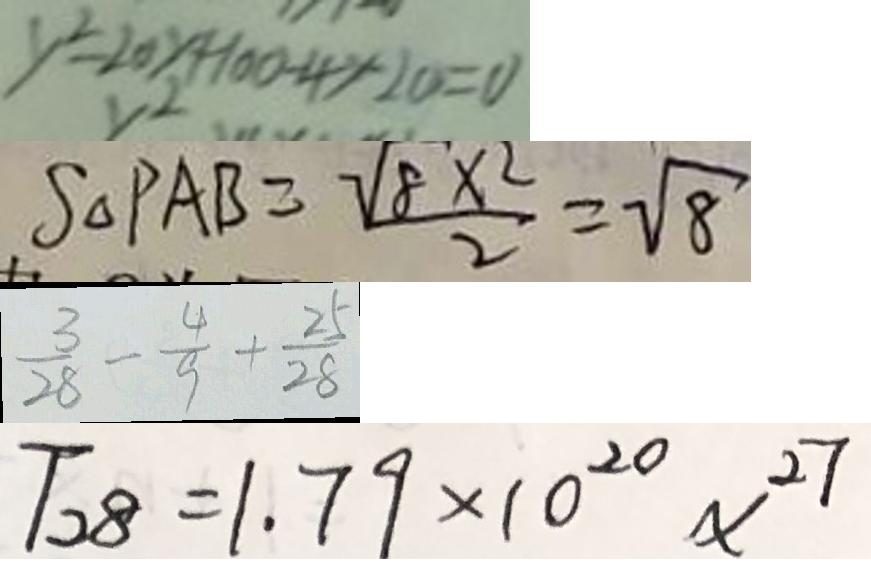<formula> <loc_0><loc_0><loc_500><loc_500>y ^ { 2 } - 2 0 y + 1 0 0 - 4 y - 2 0 = 0 
 S _ { \Delta } P A B = \frac { \sqrt { 8 } \times 2 } { 2 } = \sqrt { 8 } 
 \frac { 3 } { 2 8 } - \frac { 4 } { 9 } + \frac { 2 5 } { 2 8 } 
 T _ { 2 8 } = 1 . 7 9 \times 1 0 ^ { 2 0 } x ^ { 2 7 }</formula> 